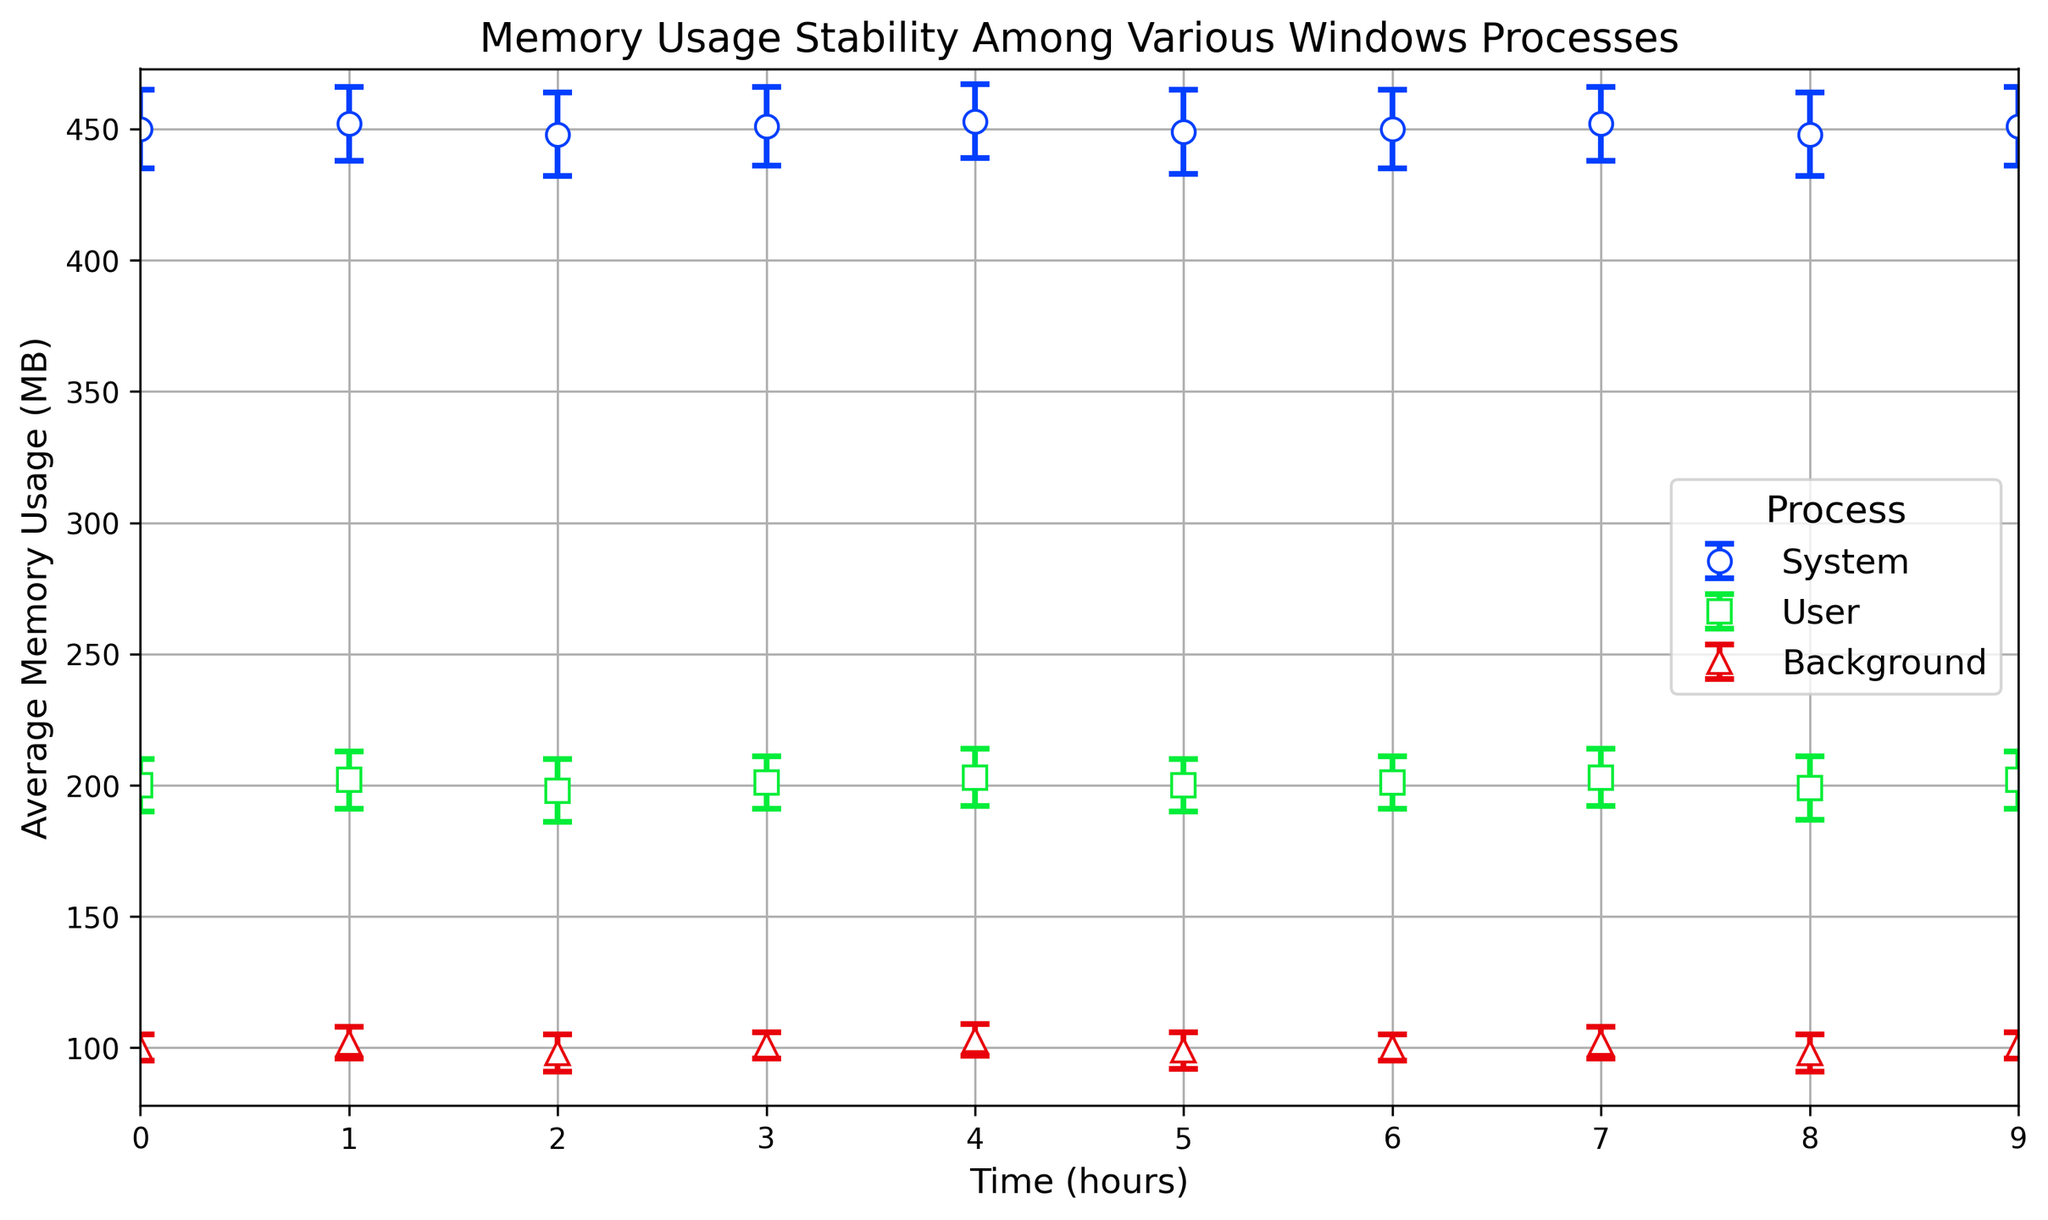How does the memory usage trend over time compare between 'System' and 'User' processes? Observing the plot, both 'System' and 'User' processes show a slight fluctuation in memory usage over time. The memory usage for 'System' processes ranges between 448 MB and 453 MB, showing a subtle up and down movement, while 'User' processes range between 198 MB and 203 MB, also fluctuating slightly over time. Both processes maintain a general stability with minor variations.
Answer: Both 'System' and 'User' processes show similar minor fluctuations in memory usage over time Which process has the lowest average memory usage over the observed time period? From the plot, it is clear that the 'Background' process has the lowest average memory usage, with values predominantly around 100 MB. In contrast, 'System' and 'User' processes have significantly higher average memory usage.
Answer: Background What is the range of the average memory usage for the 'User' processes throughout the observed time period? By looking at the error bars for the 'User' processes, the lowest point on the error bars comes at around 198 MB, while the highest point is around 203 MB. This range is the difference between the highest and lowest memory usage observed.
Answer: 198-203 MB Which process exhibits the highest standard deviation in memory usage? Examining the error bars on the plot, the 'Background' process shows error bars changing from 5 MB to 7 MB, indicating that it has a higher standard deviation compared to 'System' and 'User' processes, which have smaller and more consistent standard deviations around 14-16 MB and 10-12 MB, respectively.
Answer: Background Consider the error bars for all processes at Time = 5. Compare their range and indicate which process seems most stable at this point. At Time = 5, the 'System' process has an average memory usage around 449 MB with an error bar extending +/- 16 MB. The 'User' process has an average memory usage of 200 MB with an error bar extending +/- 10 MB. The 'Background' process has an average of 99 MB with an error bar extending +/- 7 MB. The total range for error bars of 'Background' is smaller than the others.
Answer: Background Which process had the highest average memory usage at any single point in time? By referring to the plotted data points, the 'System' process has the highest average memory usage, reaching approximately 453 MB at Time = 4 and Time = 7. No other process exceeds this value.
Answer: System How does the stability in memory usage of 'Background' processes compare to that of 'System' processes? Stability in this context is measured by looking at the length of the error bars; shorter error bars indicate less variability. 'Background' processes have error bars ranging from 5 MB to 7 MB, showing very little variability. 'System' processes, however, have error bars ranging from 14 MB to 16 MB, indicating more variability in memory usage. Thus, 'Background' processes are more stable.
Answer: Background processes are more stable Calculate the average memory usage for 'System' processes over the observed time period. To find the average, sum all the average memory usages for 'System' processes and divide by the number of observations (450+452+448+451+453+449+450+452+448+451)/10.
Answer: 450.4 MB 